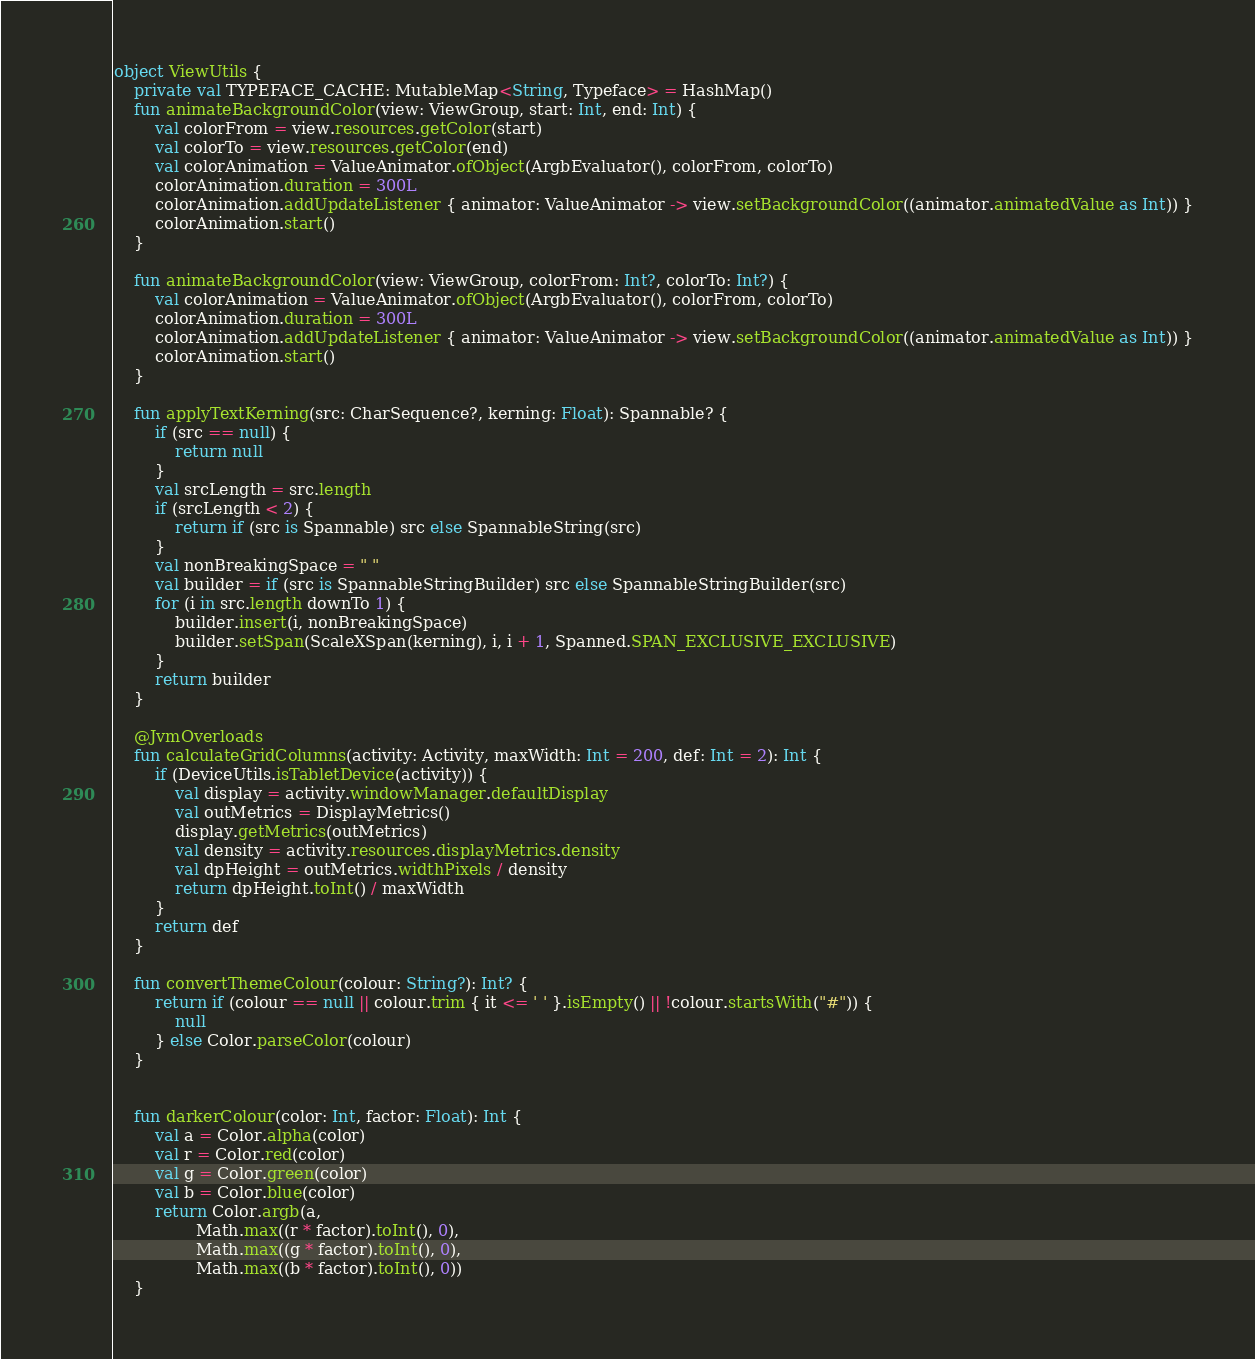<code> <loc_0><loc_0><loc_500><loc_500><_Kotlin_>
object ViewUtils {
    private val TYPEFACE_CACHE: MutableMap<String, Typeface> = HashMap()
    fun animateBackgroundColor(view: ViewGroup, start: Int, end: Int) {
        val colorFrom = view.resources.getColor(start)
        val colorTo = view.resources.getColor(end)
        val colorAnimation = ValueAnimator.ofObject(ArgbEvaluator(), colorFrom, colorTo)
        colorAnimation.duration = 300L
        colorAnimation.addUpdateListener { animator: ValueAnimator -> view.setBackgroundColor((animator.animatedValue as Int)) }
        colorAnimation.start()
    }

    fun animateBackgroundColor(view: ViewGroup, colorFrom: Int?, colorTo: Int?) {
        val colorAnimation = ValueAnimator.ofObject(ArgbEvaluator(), colorFrom, colorTo)
        colorAnimation.duration = 300L
        colorAnimation.addUpdateListener { animator: ValueAnimator -> view.setBackgroundColor((animator.animatedValue as Int)) }
        colorAnimation.start()
    }

    fun applyTextKerning(src: CharSequence?, kerning: Float): Spannable? {
        if (src == null) {
            return null
        }
        val srcLength = src.length
        if (srcLength < 2) {
            return if (src is Spannable) src else SpannableString(src)
        }
        val nonBreakingSpace = " "
        val builder = if (src is SpannableStringBuilder) src else SpannableStringBuilder(src)
        for (i in src.length downTo 1) {
            builder.insert(i, nonBreakingSpace)
            builder.setSpan(ScaleXSpan(kerning), i, i + 1, Spanned.SPAN_EXCLUSIVE_EXCLUSIVE)
        }
        return builder
    }

    @JvmOverloads
    fun calculateGridColumns(activity: Activity, maxWidth: Int = 200, def: Int = 2): Int {
        if (DeviceUtils.isTabletDevice(activity)) {
            val display = activity.windowManager.defaultDisplay
            val outMetrics = DisplayMetrics()
            display.getMetrics(outMetrics)
            val density = activity.resources.displayMetrics.density
            val dpHeight = outMetrics.widthPixels / density
            return dpHeight.toInt() / maxWidth
        }
        return def
    }

    fun convertThemeColour(colour: String?): Int? {
        return if (colour == null || colour.trim { it <= ' ' }.isEmpty() || !colour.startsWith("#")) {
            null
        } else Color.parseColor(colour)
    }


    fun darkerColour(color: Int, factor: Float): Int {
        val a = Color.alpha(color)
        val r = Color.red(color)
        val g = Color.green(color)
        val b = Color.blue(color)
        return Color.argb(a,
                Math.max((r * factor).toInt(), 0),
                Math.max((g * factor).toInt(), 0),
                Math.max((b * factor).toInt(), 0))
    }
</code> 